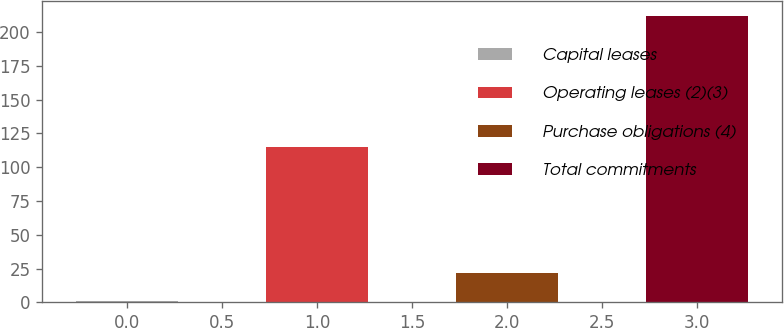Convert chart to OTSL. <chart><loc_0><loc_0><loc_500><loc_500><bar_chart><fcel>Capital leases<fcel>Operating leases (2)(3)<fcel>Purchase obligations (4)<fcel>Total commitments<nl><fcel>1<fcel>115<fcel>22.1<fcel>212<nl></chart> 